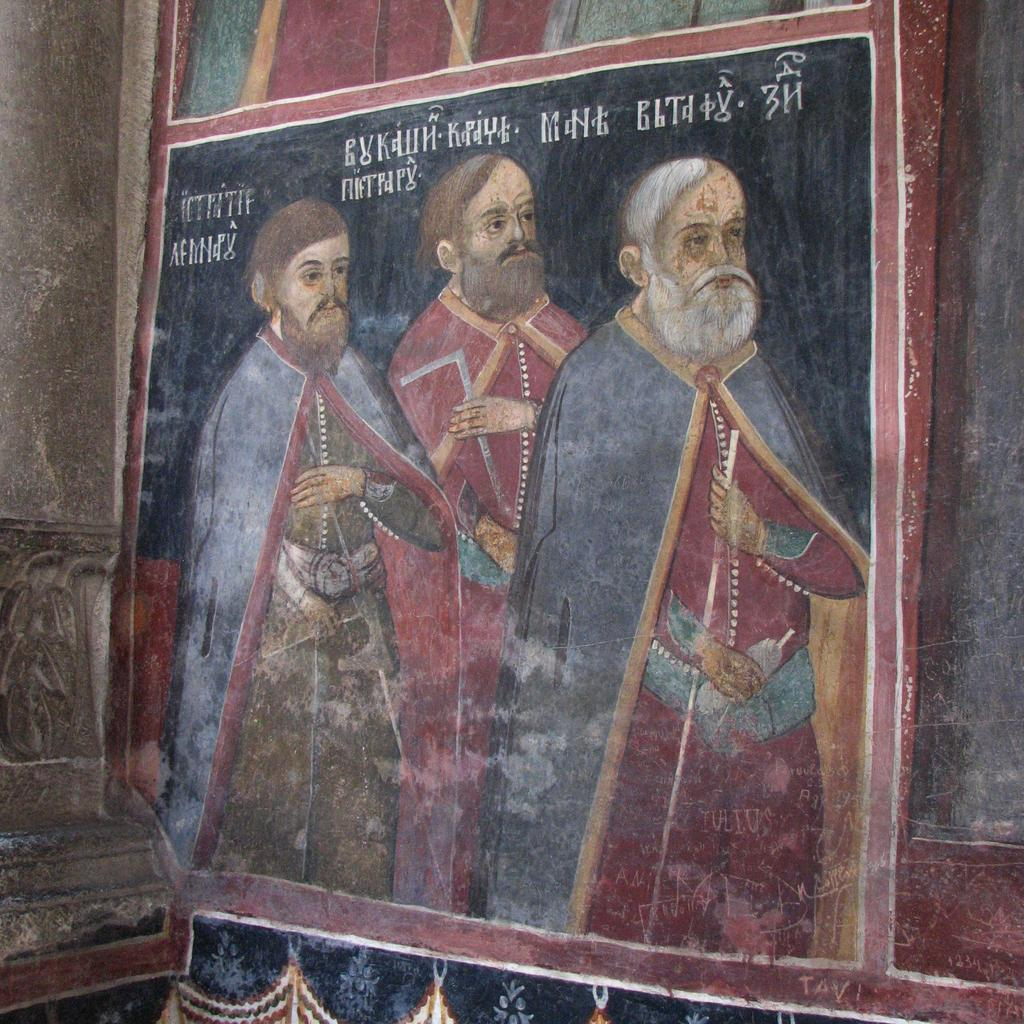What is the main subject of the image? There is a painting in the image. What is depicted in the painting? The painting depicts three persons in different color dresses standing, and there are tests in the painting. Where is the painting located in the image? The painting is near other paintings on the wall. What can be seen on the left side of the image? There is a wall on the left side of the image. Can you tell me how many scarecrows are present in the painting? There are no scarecrows depicted in the painting; it features three persons in different color dresses standing and tests. What type of judge is shown in the painting? There is no judge present in the painting; it depicts three persons in different color dresses standing and tests. 